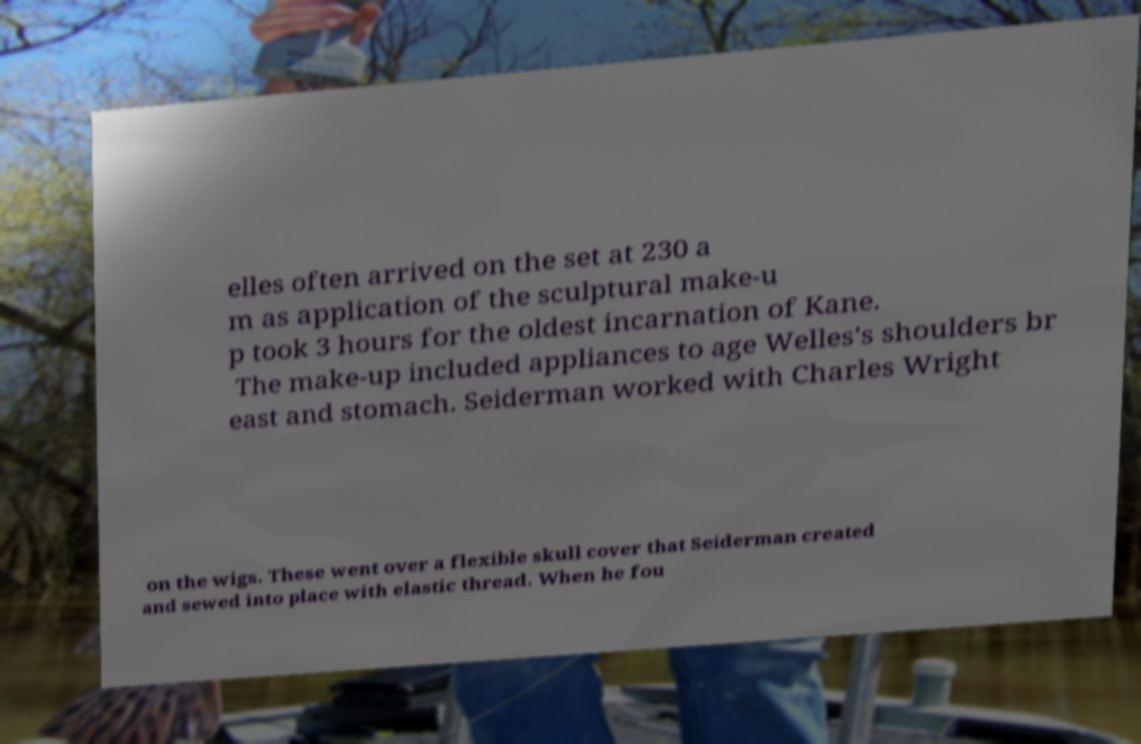Could you extract and type out the text from this image? elles often arrived on the set at 230 a m as application of the sculptural make-u p took 3 hours for the oldest incarnation of Kane. The make-up included appliances to age Welles's shoulders br east and stomach. Seiderman worked with Charles Wright on the wigs. These went over a flexible skull cover that Seiderman created and sewed into place with elastic thread. When he fou 